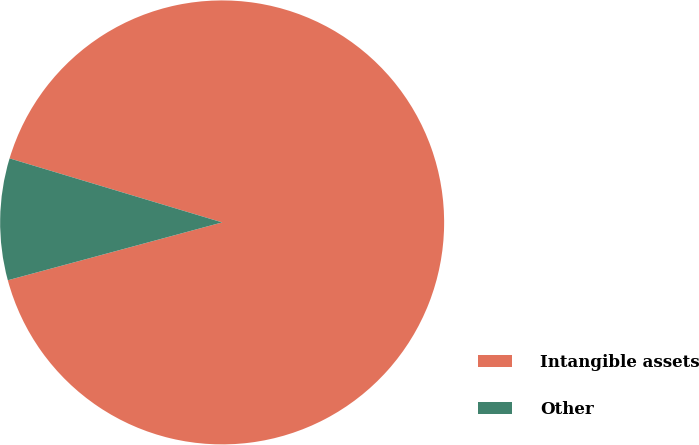<chart> <loc_0><loc_0><loc_500><loc_500><pie_chart><fcel>Intangible assets<fcel>Other<nl><fcel>91.15%<fcel>8.85%<nl></chart> 